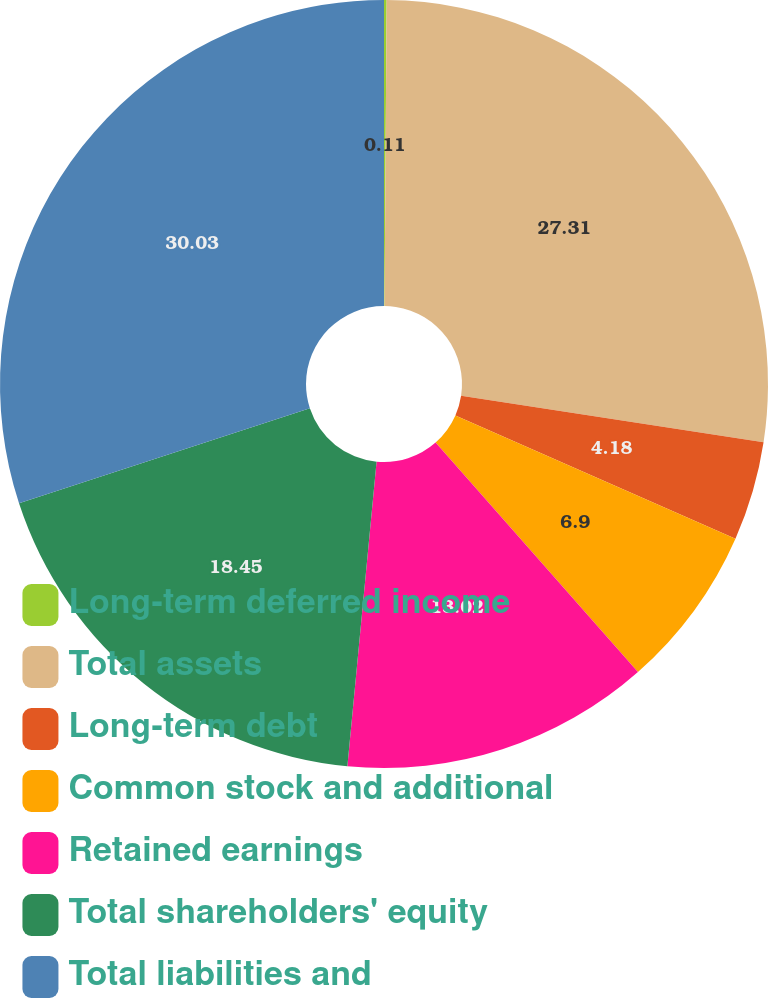<chart> <loc_0><loc_0><loc_500><loc_500><pie_chart><fcel>Long-term deferred income<fcel>Total assets<fcel>Long-term debt<fcel>Common stock and additional<fcel>Retained earnings<fcel>Total shareholders' equity<fcel>Total liabilities and<nl><fcel>0.11%<fcel>27.31%<fcel>4.18%<fcel>6.9%<fcel>13.02%<fcel>18.45%<fcel>30.03%<nl></chart> 